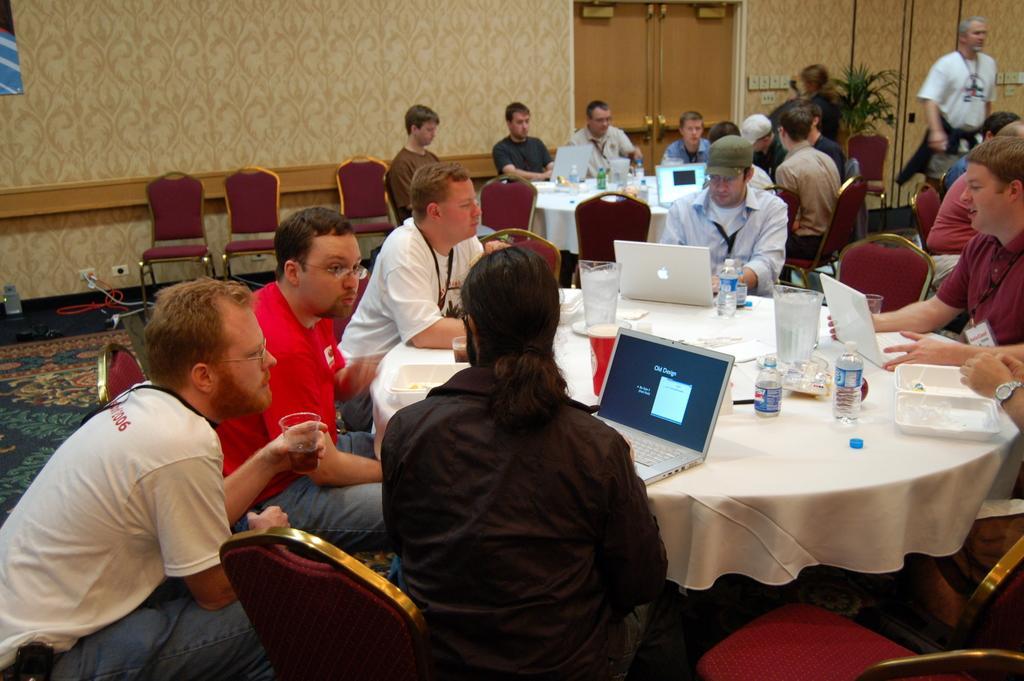How would you summarize this image in a sentence or two? There is a room. There is a group of people. They are sitting in a chair. There is a table. There is a laptop,water bottle,glass and tissue on a table. On the right side we have a person. His standing and his wearing id card. We can see in the background there is door ,chair and flower pot. 